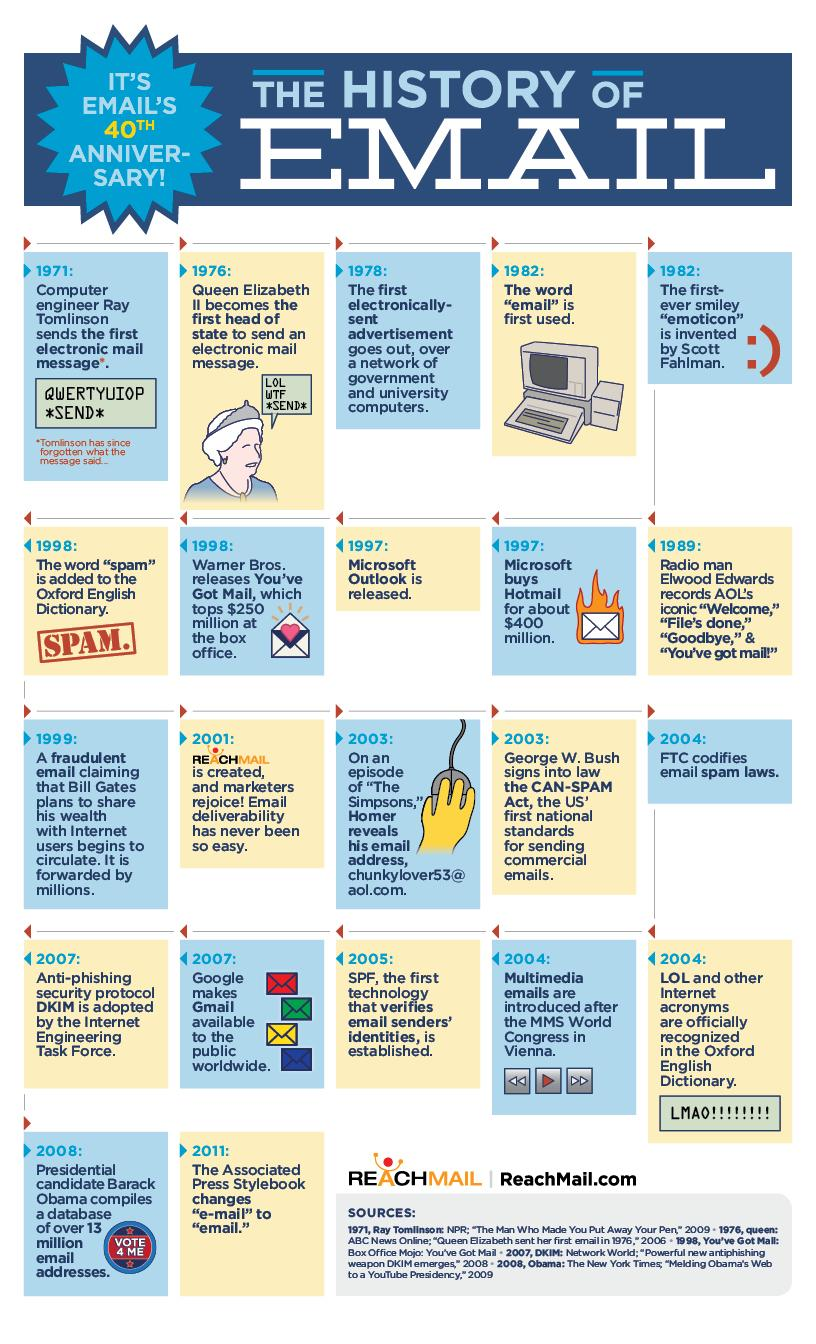Give some essential details in this illustration. Ray Tomlinson is credited with being the first person to send an email in 1971. Queen Elizabeth was the first political leader to send an email. In 2007, DKIM was adopted and GMail was introduced. In 1976, a political head was the first to send an email. In 1997, Microsoft introduced Outlook and also purchased Hotmail. 